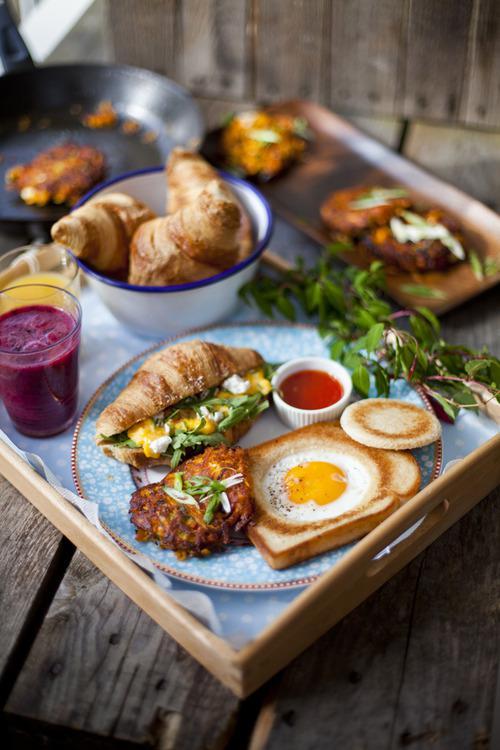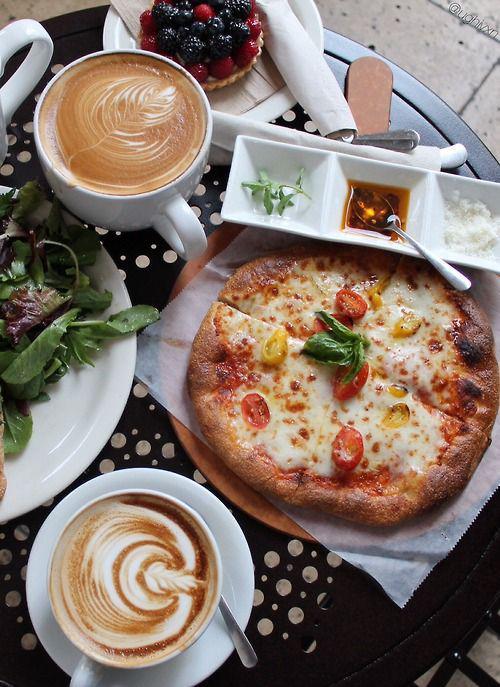The first image is the image on the left, the second image is the image on the right. For the images displayed, is the sentence "The right image shows only breakfast pizza." factually correct? Answer yes or no. No. The first image is the image on the left, the second image is the image on the right. Considering the images on both sides, is "A whole pizza is on the table." valid? Answer yes or no. Yes. 